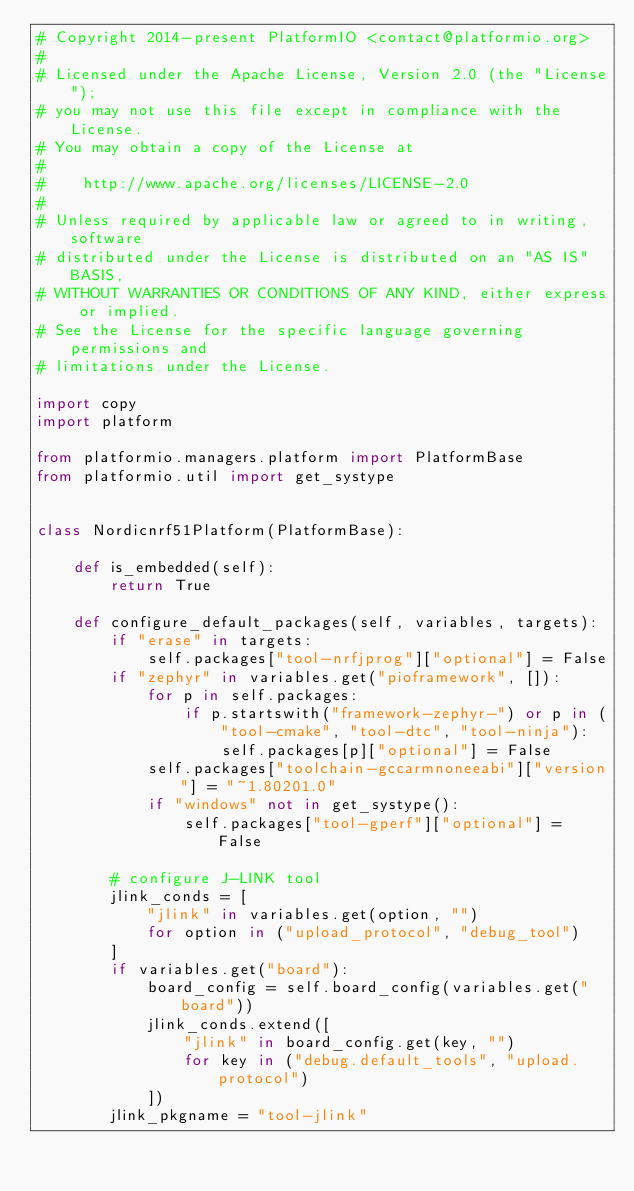Convert code to text. <code><loc_0><loc_0><loc_500><loc_500><_Python_># Copyright 2014-present PlatformIO <contact@platformio.org>
#
# Licensed under the Apache License, Version 2.0 (the "License");
# you may not use this file except in compliance with the License.
# You may obtain a copy of the License at
#
#    http://www.apache.org/licenses/LICENSE-2.0
#
# Unless required by applicable law or agreed to in writing, software
# distributed under the License is distributed on an "AS IS" BASIS,
# WITHOUT WARRANTIES OR CONDITIONS OF ANY KIND, either express or implied.
# See the License for the specific language governing permissions and
# limitations under the License.

import copy
import platform

from platformio.managers.platform import PlatformBase
from platformio.util import get_systype


class Nordicnrf51Platform(PlatformBase):

    def is_embedded(self):
        return True

    def configure_default_packages(self, variables, targets):
        if "erase" in targets:
            self.packages["tool-nrfjprog"]["optional"] = False
        if "zephyr" in variables.get("pioframework", []):
            for p in self.packages:
                if p.startswith("framework-zephyr-") or p in (
                    "tool-cmake", "tool-dtc", "tool-ninja"):
                    self.packages[p]["optional"] = False
            self.packages["toolchain-gccarmnoneeabi"]["version"] = "~1.80201.0"
            if "windows" not in get_systype():
                self.packages["tool-gperf"]["optional"] = False

        # configure J-LINK tool
        jlink_conds = [
            "jlink" in variables.get(option, "")
            for option in ("upload_protocol", "debug_tool")
        ]
        if variables.get("board"):
            board_config = self.board_config(variables.get("board"))
            jlink_conds.extend([
                "jlink" in board_config.get(key, "")
                for key in ("debug.default_tools", "upload.protocol")
            ])
        jlink_pkgname = "tool-jlink"</code> 